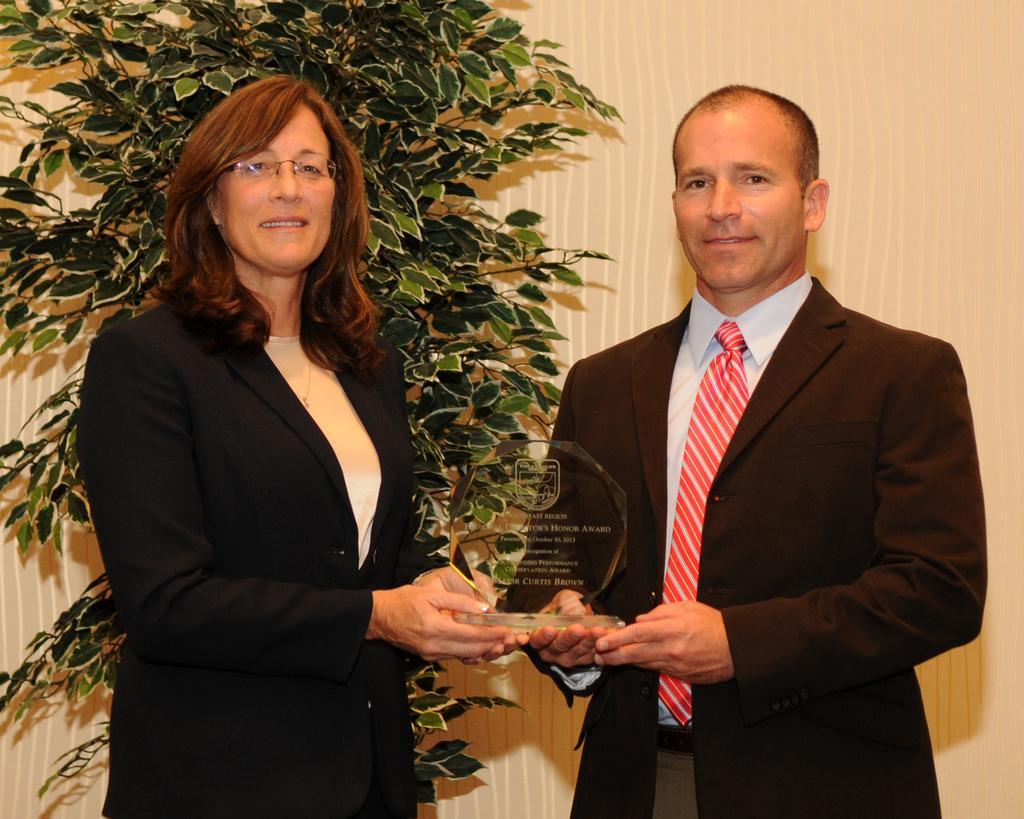Can you describe this image briefly? In this image I can see a woman and a man standing, smiling and giving pose for the picture. They are holding a glass object in their hands. In the background there is a plant and curtain. 